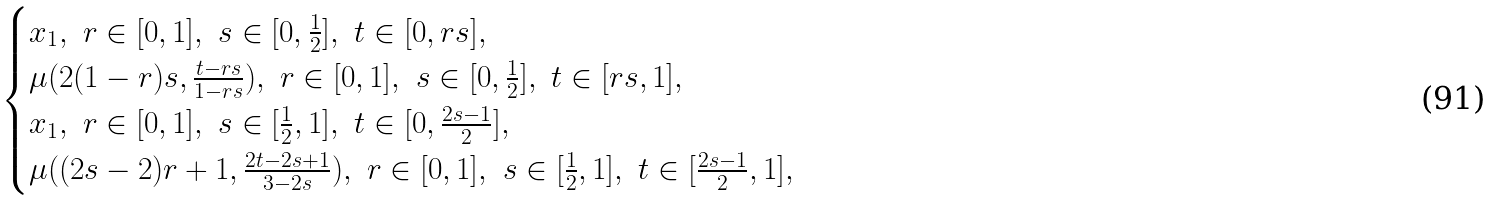Convert formula to latex. <formula><loc_0><loc_0><loc_500><loc_500>\begin{cases} x _ { 1 } , \ r \in [ 0 , 1 ] , \ s \in [ 0 , \frac { 1 } { 2 } ] , \ t \in [ 0 , r s ] , \\ \mu ( 2 ( 1 - r ) s , \frac { t - r s } { 1 - r s } ) , \ r \in [ 0 , 1 ] , \ s \in [ 0 , \frac { 1 } { 2 } ] , \ t \in [ r s , 1 ] , \\ x _ { 1 } , \ r \in [ 0 , 1 ] , \ s \in [ \frac { 1 } { 2 } , 1 ] , \ t \in [ 0 , \frac { 2 s - 1 } { 2 } ] , \\ \mu ( ( 2 s - 2 ) r + 1 , \frac { 2 t - 2 s + 1 } { 3 - 2 s } ) , \ r \in [ 0 , 1 ] , \ s \in [ \frac { 1 } { 2 } , 1 ] , \ t \in [ \frac { 2 s - 1 } { 2 } , 1 ] , \\ \end{cases}</formula> 